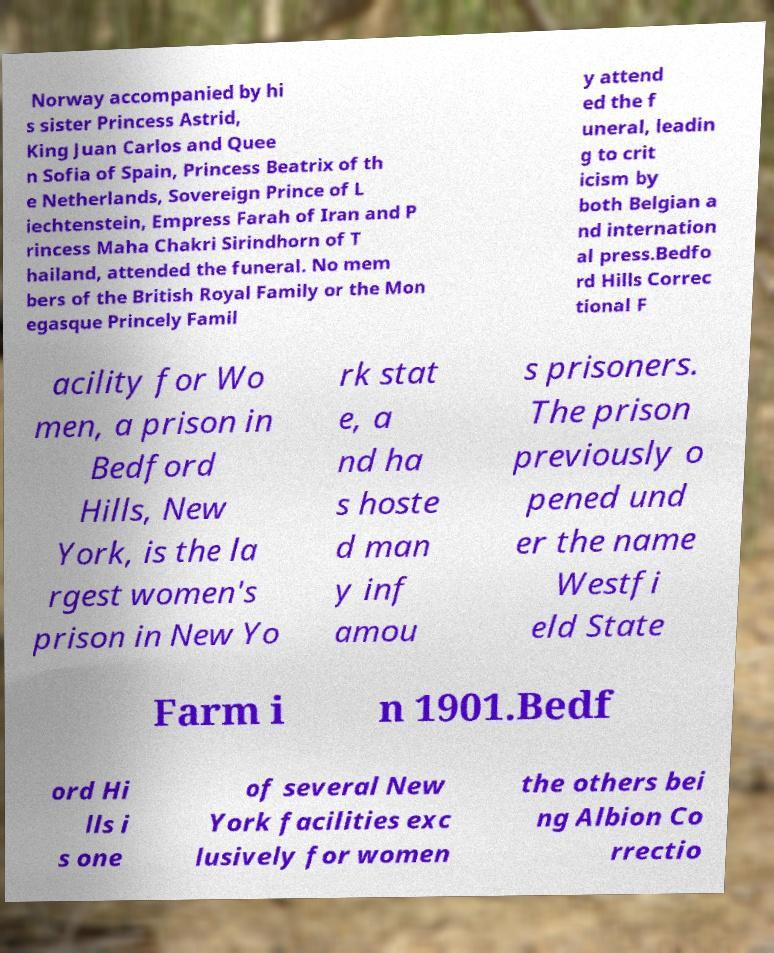Can you accurately transcribe the text from the provided image for me? Norway accompanied by hi s sister Princess Astrid, King Juan Carlos and Quee n Sofia of Spain, Princess Beatrix of th e Netherlands, Sovereign Prince of L iechtenstein, Empress Farah of Iran and P rincess Maha Chakri Sirindhorn of T hailand, attended the funeral. No mem bers of the British Royal Family or the Mon egasque Princely Famil y attend ed the f uneral, leadin g to crit icism by both Belgian a nd internation al press.Bedfo rd Hills Correc tional F acility for Wo men, a prison in Bedford Hills, New York, is the la rgest women's prison in New Yo rk stat e, a nd ha s hoste d man y inf amou s prisoners. The prison previously o pened und er the name Westfi eld State Farm i n 1901.Bedf ord Hi lls i s one of several New York facilities exc lusively for women the others bei ng Albion Co rrectio 